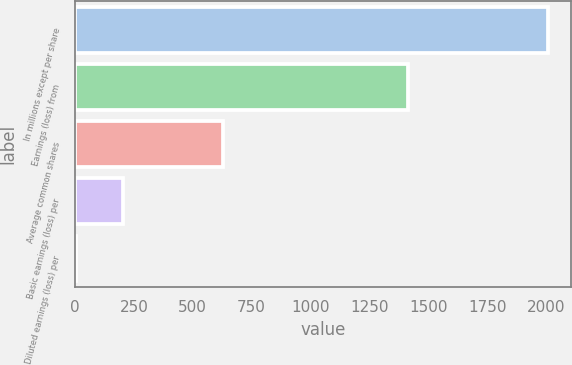Convert chart. <chart><loc_0><loc_0><loc_500><loc_500><bar_chart><fcel>In millions except per share<fcel>Earnings (loss) from<fcel>Average common shares<fcel>Basic earnings (loss) per<fcel>Diluted earnings (loss) per<nl><fcel>2007<fcel>1415.42<fcel>629.32<fcel>203.23<fcel>2.81<nl></chart> 